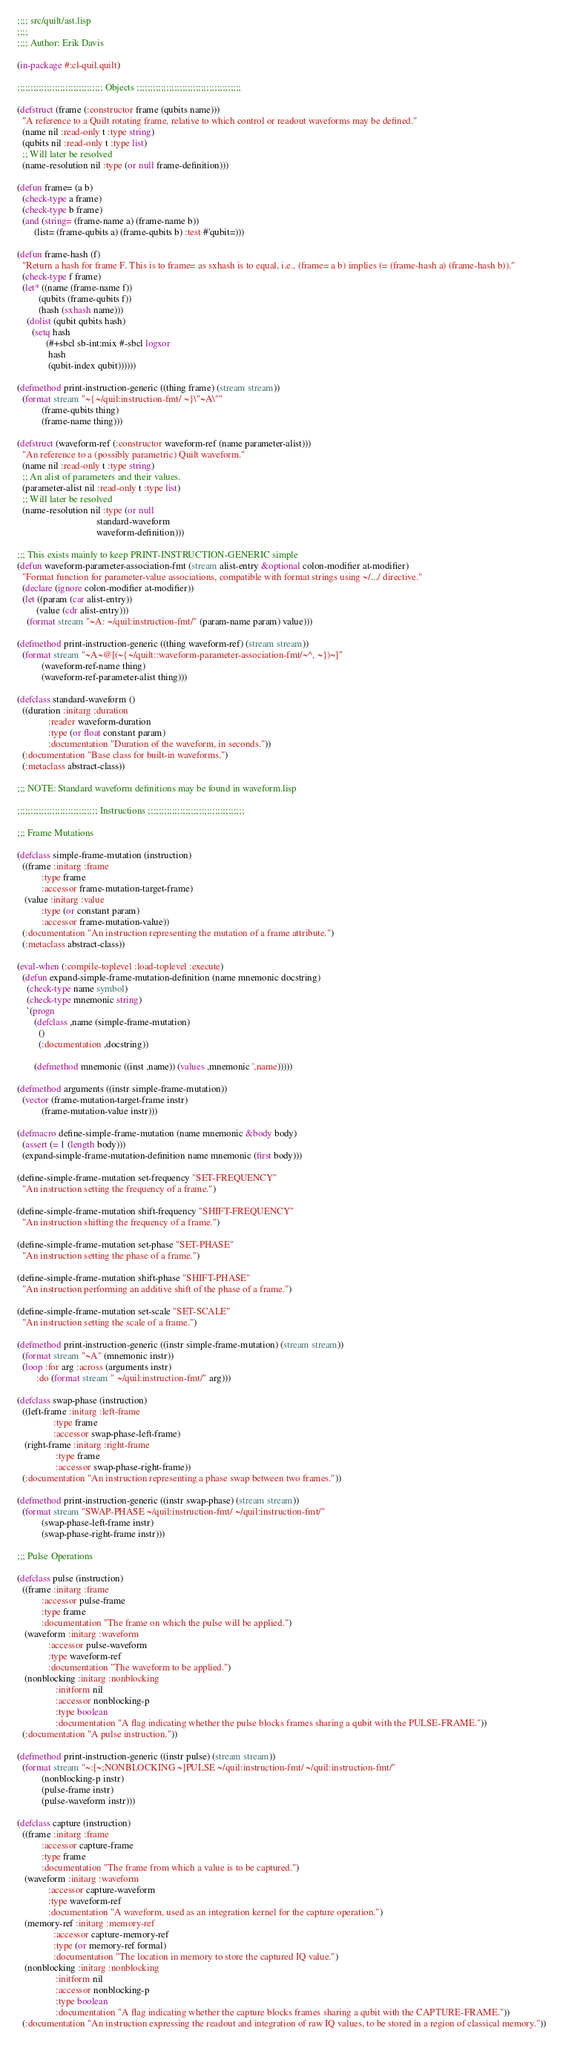Convert code to text. <code><loc_0><loc_0><loc_500><loc_500><_Lisp_>;;;; src/quilt/ast.lisp
;;;;
;;;; Author: Erik Davis

(in-package #:cl-quil.quilt)

;;;;;;;;;;;;;;;;;;;;;;;;;;;;;;;; Objects ;;;;;;;;;;;;;;;;;;;;;;;;;;;;;;;;;;;;;;;

(defstruct (frame (:constructor frame (qubits name)))
  "A reference to a Quilt rotating frame, relative to which control or readout waveforms may be defined."
  (name nil :read-only t :type string)
  (qubits nil :read-only t :type list)
  ;; Will later be resolved
  (name-resolution nil :type (or null frame-definition)))

(defun frame= (a b)
  (check-type a frame)
  (check-type b frame)
  (and (string= (frame-name a) (frame-name b))
       (list= (frame-qubits a) (frame-qubits b) :test #'qubit=)))

(defun frame-hash (f)
  "Return a hash for frame F. This is to frame= as sxhash is to equal, i.e., (frame= a b) implies (= (frame-hash a) (frame-hash b))."
  (check-type f frame)
  (let* ((name (frame-name f))
         (qubits (frame-qubits f))
         (hash (sxhash name)))
    (dolist (qubit qubits hash)
      (setq hash
            (#+sbcl sb-int:mix #-sbcl logxor
             hash
             (qubit-index qubit))))))

(defmethod print-instruction-generic ((thing frame) (stream stream))
  (format stream "~{~/quil:instruction-fmt/ ~}\"~A\""
          (frame-qubits thing)
          (frame-name thing)))

(defstruct (waveform-ref (:constructor waveform-ref (name parameter-alist)))
  "An reference to a (possibly parametric) Quilt waveform."
  (name nil :read-only t :type string)
  ;; An alist of parameters and their values.
  (parameter-alist nil :read-only t :type list)
  ;; Will later be resolved
  (name-resolution nil :type (or null
                                 standard-waveform
                                 waveform-definition)))

;;; This exists mainly to keep PRINT-INSTRUCTION-GENERIC simple
(defun waveform-parameter-association-fmt (stream alist-entry &optional colon-modifier at-modifier)
  "Format function for parameter-value associations, compatible with format strings using ~/.../ directive."
  (declare (ignore colon-modifier at-modifier))
  (let ((param (car alist-entry))
        (value (cdr alist-entry)))
    (format stream "~A: ~/quil:instruction-fmt/" (param-name param) value)))

(defmethod print-instruction-generic ((thing waveform-ref) (stream stream))
  (format stream "~A~@[(~{~/quilt::waveform-parameter-association-fmt/~^, ~})~]"
          (waveform-ref-name thing)
          (waveform-ref-parameter-alist thing)))

(defclass standard-waveform ()
  ((duration :initarg :duration
             :reader waveform-duration
             :type (or float constant param)
             :documentation "Duration of the waveform, in seconds."))
  (:documentation "Base class for built-in waveforms.")
  (:metaclass abstract-class))

;;; NOTE: Standard waveform definitions may be found in waveform.lisp

;;;;;;;;;;;;;;;;;;;;;;;;;;;;;; Instructions ;;;;;;;;;;;;;;;;;;;;;;;;;;;;;;;;;;;;

;;; Frame Mutations

(defclass simple-frame-mutation (instruction)
  ((frame :initarg :frame
          :type frame
          :accessor frame-mutation-target-frame)
   (value :initarg :value
          :type (or constant param)
          :accessor frame-mutation-value))
  (:documentation "An instruction representing the mutation of a frame attribute.")
  (:metaclass abstract-class))

(eval-when (:compile-toplevel :load-toplevel :execute)
  (defun expand-simple-frame-mutation-definition (name mnemonic docstring)
    (check-type name symbol)
    (check-type mnemonic string)
    `(progn
       (defclass ,name (simple-frame-mutation)
         ()
         (:documentation ,docstring))

       (defmethod mnemonic ((inst ,name)) (values ,mnemonic ',name)))))

(defmethod arguments ((instr simple-frame-mutation))
  (vector (frame-mutation-target-frame instr)
          (frame-mutation-value instr)))

(defmacro define-simple-frame-mutation (name mnemonic &body body)
  (assert (= 1 (length body)))
  (expand-simple-frame-mutation-definition name mnemonic (first body)))

(define-simple-frame-mutation set-frequency "SET-FREQUENCY"
  "An instruction setting the frequency of a frame.")

(define-simple-frame-mutation shift-frequency "SHIFT-FREQUENCY"
  "An instruction shifting the frequency of a frame.")

(define-simple-frame-mutation set-phase "SET-PHASE"
  "An instruction setting the phase of a frame.")

(define-simple-frame-mutation shift-phase "SHIFT-PHASE"
  "An instruction performing an additive shift of the phase of a frame.")

(define-simple-frame-mutation set-scale "SET-SCALE"
  "An instruction setting the scale of a frame.")

(defmethod print-instruction-generic ((instr simple-frame-mutation) (stream stream))
  (format stream "~A" (mnemonic instr))
  (loop :for arg :across (arguments instr)
        :do (format stream " ~/quil:instruction-fmt/" arg)))

(defclass swap-phase (instruction)
  ((left-frame :initarg :left-frame
               :type frame
               :accessor swap-phase-left-frame)
   (right-frame :initarg :right-frame
                :type frame
                :accessor swap-phase-right-frame))
  (:documentation "An instruction representing a phase swap between two frames."))

(defmethod print-instruction-generic ((instr swap-phase) (stream stream))
  (format stream "SWAP-PHASE ~/quil:instruction-fmt/ ~/quil:instruction-fmt/"
          (swap-phase-left-frame instr)
          (swap-phase-right-frame instr)))

;;; Pulse Operations

(defclass pulse (instruction)
  ((frame :initarg :frame
          :accessor pulse-frame
          :type frame
          :documentation "The frame on which the pulse will be applied.")
   (waveform :initarg :waveform
             :accessor pulse-waveform
             :type waveform-ref
             :documentation "The waveform to be applied.")
   (nonblocking :initarg :nonblocking
                :initform nil
                :accessor nonblocking-p
                :type boolean
                :documentation "A flag indicating whether the pulse blocks frames sharing a qubit with the PULSE-FRAME."))
  (:documentation "A pulse instruction."))

(defmethod print-instruction-generic ((instr pulse) (stream stream))
  (format stream "~:[~;NONBLOCKING ~]PULSE ~/quil:instruction-fmt/ ~/quil:instruction-fmt/"
          (nonblocking-p instr)
          (pulse-frame instr)
          (pulse-waveform instr)))

(defclass capture (instruction)
  ((frame :initarg :frame
          :accessor capture-frame
          :type frame
          :documentation "The frame from which a value is to be captured.")
   (waveform :initarg :waveform
             :accessor capture-waveform
             :type waveform-ref
             :documentation "A waveform, used as an integration kernel for the capture operation.")
   (memory-ref :initarg :memory-ref
               :accessor capture-memory-ref
               :type (or memory-ref formal)
               :documentation "The location in memory to store the captured IQ value.")
   (nonblocking :initarg :nonblocking
                :initform nil
                :accessor nonblocking-p
                :type boolean
                :documentation "A flag indicating whether the capture blocks frames sharing a qubit with the CAPTURE-FRAME."))
  (:documentation "An instruction expressing the readout and integration of raw IQ values, to be stored in a region of classical memory."))
</code> 